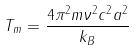<formula> <loc_0><loc_0><loc_500><loc_500>T _ { m } = \frac { 4 \pi ^ { 2 } m \nu ^ { 2 } c ^ { 2 } a ^ { 2 } } { k _ { B } }</formula> 